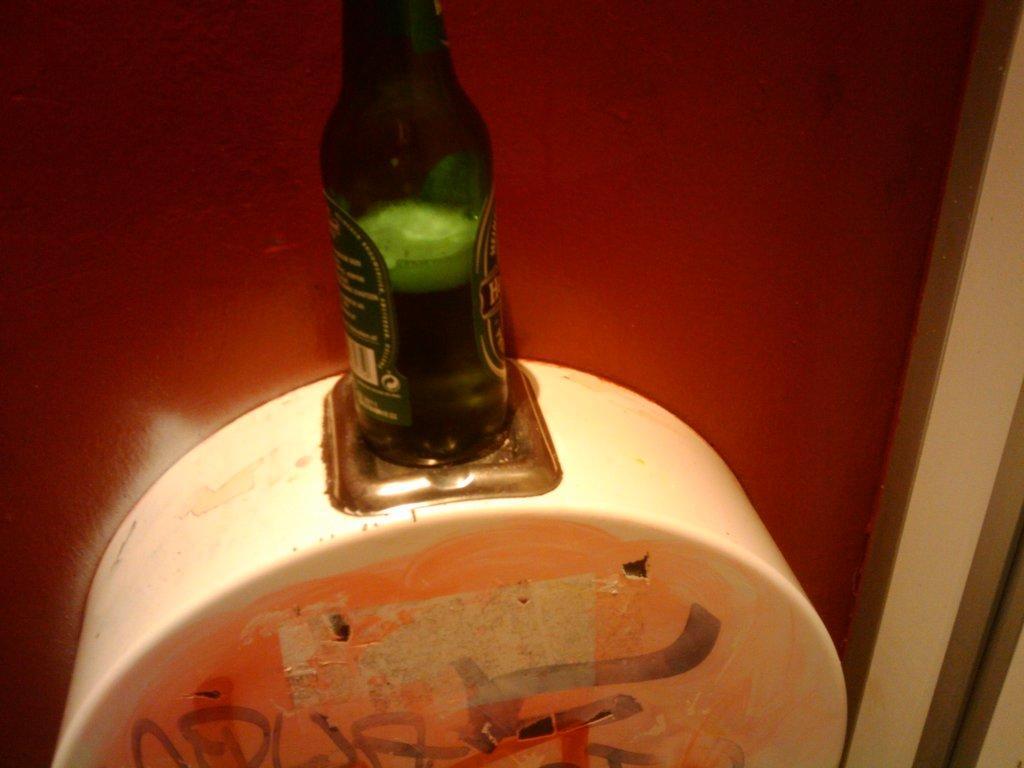Could you give a brief overview of what you see in this image? In this image I can see a green color beer bottle with alcohol in it. This is a white color object which is attached to the wall. Background is red in color. 